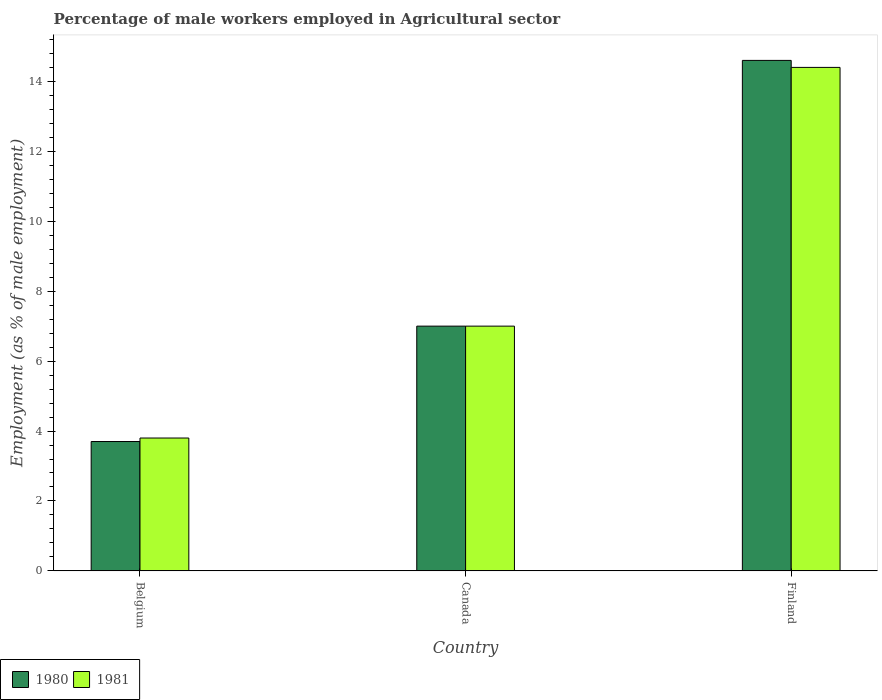Are the number of bars per tick equal to the number of legend labels?
Offer a very short reply. Yes. How many bars are there on the 3rd tick from the right?
Your response must be concise. 2. In how many cases, is the number of bars for a given country not equal to the number of legend labels?
Make the answer very short. 0. Across all countries, what is the maximum percentage of male workers employed in Agricultural sector in 1980?
Your answer should be very brief. 14.6. Across all countries, what is the minimum percentage of male workers employed in Agricultural sector in 1981?
Offer a very short reply. 3.8. In which country was the percentage of male workers employed in Agricultural sector in 1980 maximum?
Provide a succinct answer. Finland. What is the total percentage of male workers employed in Agricultural sector in 1981 in the graph?
Ensure brevity in your answer.  25.2. What is the difference between the percentage of male workers employed in Agricultural sector in 1980 in Belgium and that in Canada?
Make the answer very short. -3.3. What is the difference between the percentage of male workers employed in Agricultural sector in 1981 in Finland and the percentage of male workers employed in Agricultural sector in 1980 in Canada?
Provide a short and direct response. 7.4. What is the average percentage of male workers employed in Agricultural sector in 1981 per country?
Give a very brief answer. 8.4. What is the difference between the percentage of male workers employed in Agricultural sector of/in 1981 and percentage of male workers employed in Agricultural sector of/in 1980 in Belgium?
Ensure brevity in your answer.  0.1. In how many countries, is the percentage of male workers employed in Agricultural sector in 1980 greater than 8 %?
Your response must be concise. 1. What is the ratio of the percentage of male workers employed in Agricultural sector in 1980 in Belgium to that in Finland?
Ensure brevity in your answer.  0.25. Is the percentage of male workers employed in Agricultural sector in 1981 in Canada less than that in Finland?
Make the answer very short. Yes. Is the difference between the percentage of male workers employed in Agricultural sector in 1981 in Belgium and Canada greater than the difference between the percentage of male workers employed in Agricultural sector in 1980 in Belgium and Canada?
Offer a very short reply. Yes. What is the difference between the highest and the second highest percentage of male workers employed in Agricultural sector in 1980?
Offer a very short reply. -10.9. What is the difference between the highest and the lowest percentage of male workers employed in Agricultural sector in 1980?
Offer a very short reply. 10.9. Is the sum of the percentage of male workers employed in Agricultural sector in 1980 in Canada and Finland greater than the maximum percentage of male workers employed in Agricultural sector in 1981 across all countries?
Offer a terse response. Yes. What does the 2nd bar from the left in Canada represents?
Provide a short and direct response. 1981. Are all the bars in the graph horizontal?
Your response must be concise. No. How many countries are there in the graph?
Your answer should be very brief. 3. Where does the legend appear in the graph?
Your answer should be compact. Bottom left. How many legend labels are there?
Give a very brief answer. 2. How are the legend labels stacked?
Offer a terse response. Horizontal. What is the title of the graph?
Make the answer very short. Percentage of male workers employed in Agricultural sector. What is the label or title of the X-axis?
Provide a short and direct response. Country. What is the label or title of the Y-axis?
Offer a terse response. Employment (as % of male employment). What is the Employment (as % of male employment) in 1980 in Belgium?
Offer a terse response. 3.7. What is the Employment (as % of male employment) of 1981 in Belgium?
Provide a succinct answer. 3.8. What is the Employment (as % of male employment) in 1981 in Canada?
Provide a succinct answer. 7. What is the Employment (as % of male employment) in 1980 in Finland?
Offer a very short reply. 14.6. What is the Employment (as % of male employment) in 1981 in Finland?
Ensure brevity in your answer.  14.4. Across all countries, what is the maximum Employment (as % of male employment) of 1980?
Make the answer very short. 14.6. Across all countries, what is the maximum Employment (as % of male employment) of 1981?
Offer a very short reply. 14.4. Across all countries, what is the minimum Employment (as % of male employment) in 1980?
Give a very brief answer. 3.7. Across all countries, what is the minimum Employment (as % of male employment) in 1981?
Your answer should be very brief. 3.8. What is the total Employment (as % of male employment) in 1980 in the graph?
Give a very brief answer. 25.3. What is the total Employment (as % of male employment) in 1981 in the graph?
Your response must be concise. 25.2. What is the difference between the Employment (as % of male employment) in 1980 in Belgium and that in Canada?
Offer a terse response. -3.3. What is the difference between the Employment (as % of male employment) in 1981 in Belgium and that in Finland?
Your response must be concise. -10.6. What is the difference between the Employment (as % of male employment) in 1981 in Canada and that in Finland?
Your answer should be very brief. -7.4. What is the difference between the Employment (as % of male employment) of 1980 in Belgium and the Employment (as % of male employment) of 1981 in Canada?
Your answer should be compact. -3.3. What is the difference between the Employment (as % of male employment) of 1980 in Belgium and the Employment (as % of male employment) of 1981 in Finland?
Provide a succinct answer. -10.7. What is the average Employment (as % of male employment) of 1980 per country?
Keep it short and to the point. 8.43. What is the average Employment (as % of male employment) in 1981 per country?
Offer a terse response. 8.4. What is the difference between the Employment (as % of male employment) of 1980 and Employment (as % of male employment) of 1981 in Belgium?
Offer a terse response. -0.1. What is the difference between the Employment (as % of male employment) in 1980 and Employment (as % of male employment) in 1981 in Finland?
Keep it short and to the point. 0.2. What is the ratio of the Employment (as % of male employment) of 1980 in Belgium to that in Canada?
Provide a short and direct response. 0.53. What is the ratio of the Employment (as % of male employment) of 1981 in Belgium to that in Canada?
Give a very brief answer. 0.54. What is the ratio of the Employment (as % of male employment) of 1980 in Belgium to that in Finland?
Make the answer very short. 0.25. What is the ratio of the Employment (as % of male employment) in 1981 in Belgium to that in Finland?
Provide a short and direct response. 0.26. What is the ratio of the Employment (as % of male employment) of 1980 in Canada to that in Finland?
Keep it short and to the point. 0.48. What is the ratio of the Employment (as % of male employment) of 1981 in Canada to that in Finland?
Keep it short and to the point. 0.49. What is the difference between the highest and the second highest Employment (as % of male employment) in 1980?
Your answer should be compact. 7.6. What is the difference between the highest and the second highest Employment (as % of male employment) in 1981?
Offer a terse response. 7.4. 